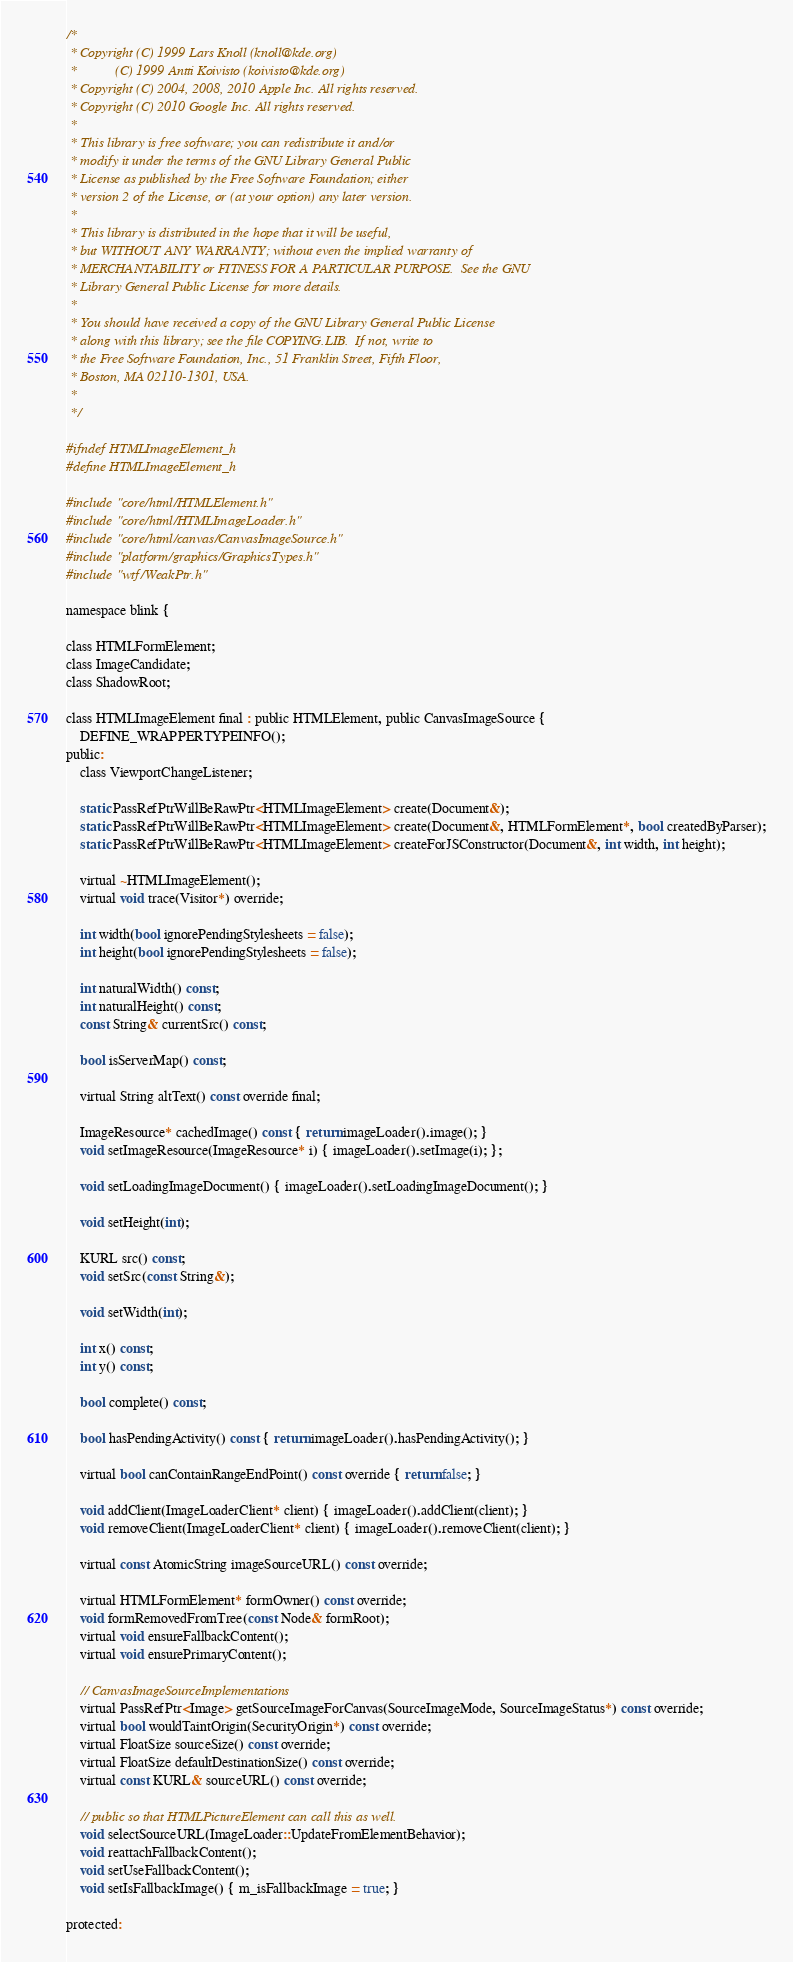Convert code to text. <code><loc_0><loc_0><loc_500><loc_500><_C_>/*
 * Copyright (C) 1999 Lars Knoll (knoll@kde.org)
 *           (C) 1999 Antti Koivisto (koivisto@kde.org)
 * Copyright (C) 2004, 2008, 2010 Apple Inc. All rights reserved.
 * Copyright (C) 2010 Google Inc. All rights reserved.
 *
 * This library is free software; you can redistribute it and/or
 * modify it under the terms of the GNU Library General Public
 * License as published by the Free Software Foundation; either
 * version 2 of the License, or (at your option) any later version.
 *
 * This library is distributed in the hope that it will be useful,
 * but WITHOUT ANY WARRANTY; without even the implied warranty of
 * MERCHANTABILITY or FITNESS FOR A PARTICULAR PURPOSE.  See the GNU
 * Library General Public License for more details.
 *
 * You should have received a copy of the GNU Library General Public License
 * along with this library; see the file COPYING.LIB.  If not, write to
 * the Free Software Foundation, Inc., 51 Franklin Street, Fifth Floor,
 * Boston, MA 02110-1301, USA.
 *
 */

#ifndef HTMLImageElement_h
#define HTMLImageElement_h

#include "core/html/HTMLElement.h"
#include "core/html/HTMLImageLoader.h"
#include "core/html/canvas/CanvasImageSource.h"
#include "platform/graphics/GraphicsTypes.h"
#include "wtf/WeakPtr.h"

namespace blink {

class HTMLFormElement;
class ImageCandidate;
class ShadowRoot;

class HTMLImageElement final : public HTMLElement, public CanvasImageSource {
    DEFINE_WRAPPERTYPEINFO();
public:
    class ViewportChangeListener;

    static PassRefPtrWillBeRawPtr<HTMLImageElement> create(Document&);
    static PassRefPtrWillBeRawPtr<HTMLImageElement> create(Document&, HTMLFormElement*, bool createdByParser);
    static PassRefPtrWillBeRawPtr<HTMLImageElement> createForJSConstructor(Document&, int width, int height);

    virtual ~HTMLImageElement();
    virtual void trace(Visitor*) override;

    int width(bool ignorePendingStylesheets = false);
    int height(bool ignorePendingStylesheets = false);

    int naturalWidth() const;
    int naturalHeight() const;
    const String& currentSrc() const;

    bool isServerMap() const;

    virtual String altText() const override final;

    ImageResource* cachedImage() const { return imageLoader().image(); }
    void setImageResource(ImageResource* i) { imageLoader().setImage(i); };

    void setLoadingImageDocument() { imageLoader().setLoadingImageDocument(); }

    void setHeight(int);

    KURL src() const;
    void setSrc(const String&);

    void setWidth(int);

    int x() const;
    int y() const;

    bool complete() const;

    bool hasPendingActivity() const { return imageLoader().hasPendingActivity(); }

    virtual bool canContainRangeEndPoint() const override { return false; }

    void addClient(ImageLoaderClient* client) { imageLoader().addClient(client); }
    void removeClient(ImageLoaderClient* client) { imageLoader().removeClient(client); }

    virtual const AtomicString imageSourceURL() const override;

    virtual HTMLFormElement* formOwner() const override;
    void formRemovedFromTree(const Node& formRoot);
    virtual void ensureFallbackContent();
    virtual void ensurePrimaryContent();

    // CanvasImageSourceImplementations
    virtual PassRefPtr<Image> getSourceImageForCanvas(SourceImageMode, SourceImageStatus*) const override;
    virtual bool wouldTaintOrigin(SecurityOrigin*) const override;
    virtual FloatSize sourceSize() const override;
    virtual FloatSize defaultDestinationSize() const override;
    virtual const KURL& sourceURL() const override;

    // public so that HTMLPictureElement can call this as well.
    void selectSourceURL(ImageLoader::UpdateFromElementBehavior);
    void reattachFallbackContent();
    void setUseFallbackContent();
    void setIsFallbackImage() { m_isFallbackImage = true; }

protected:</code> 